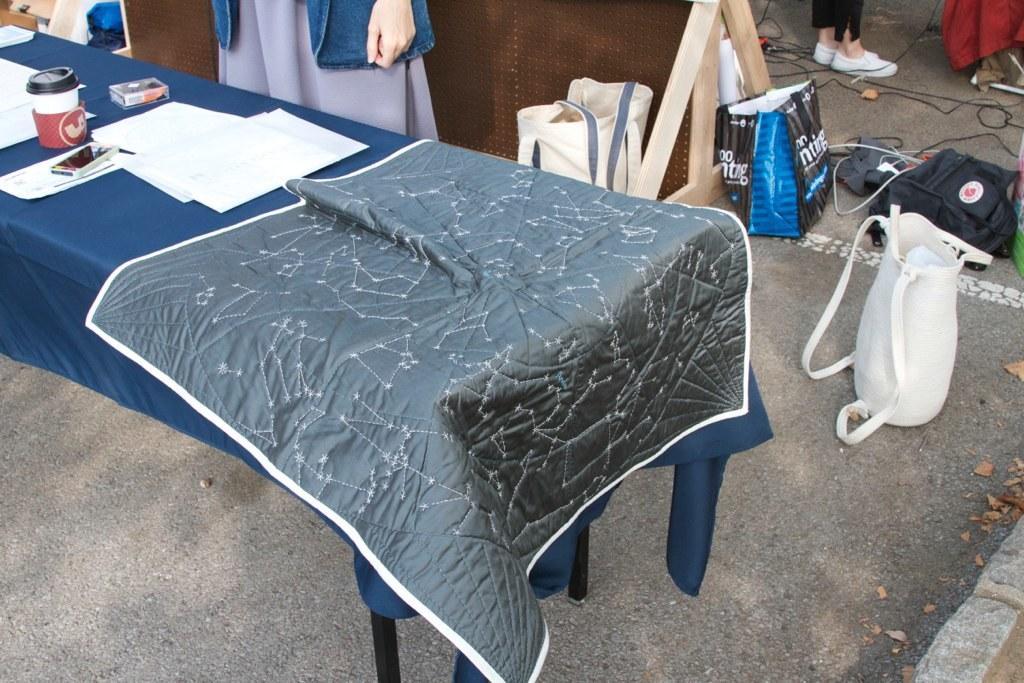Please provide a concise description of this image. In this image there is a table truncated towards the left of the image, there is a cloth on the table, there are objects on the table, there is road truncated towards the bottom of the image, there are objects on the road, there are persons truncated towards the top of the image, there is a board truncated towards the top of the image, there are bags, there are wires truncated. 